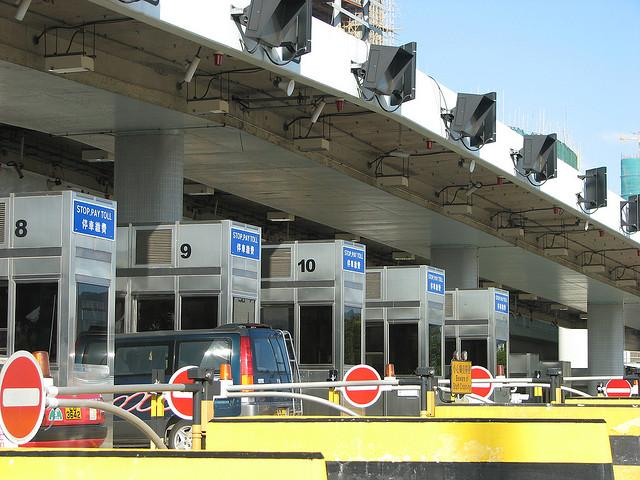What does the red sign with a minus symbol on it usually mean?

Choices:
A) free parking
B) no parking
C) no entering
D) crossing permitted no entering 